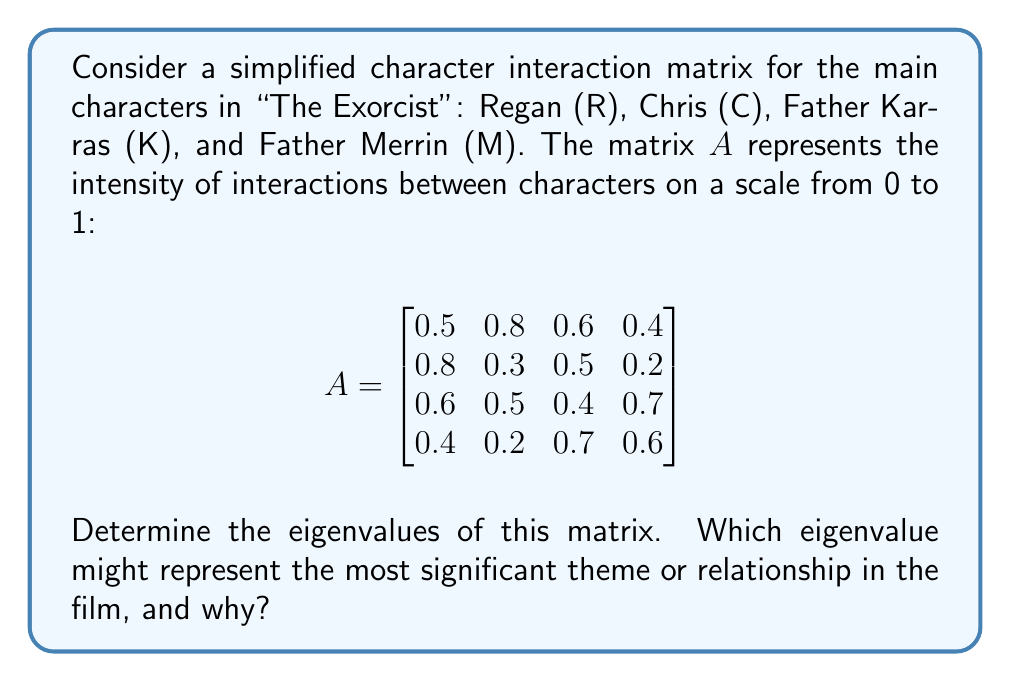Can you answer this question? To find the eigenvalues of matrix $A$, we need to solve the characteristic equation:

$$\det(A - \lambda I) = 0$$

Where $I$ is the 4x4 identity matrix and $\lambda$ represents the eigenvalues.

1) First, let's set up the matrix $A - \lambda I$:

$$A - \lambda I = \begin{bmatrix}
0.5-\lambda & 0.8 & 0.6 & 0.4 \\
0.8 & 0.3-\lambda & 0.5 & 0.2 \\
0.6 & 0.5 & 0.4-\lambda & 0.7 \\
0.4 & 0.2 & 0.7 & 0.6-\lambda
\end{bmatrix}$$

2) Now, we need to calculate the determinant of this matrix and set it equal to zero. This gives us the characteristic polynomial:

$$\lambda^4 - 1.8\lambda^3 - 0.7625\lambda^2 + 0.9715\lambda - 0.1296 = 0$$

3) Solving this equation gives us the eigenvalues. While it's possible to solve this by hand, it's computationally intensive. Using a numerical method, we get the following eigenvalues:

$$\lambda_1 \approx 1.8997$$
$$\lambda_2 \approx 0.2667$$
$$\lambda_3 \approx -0.2332$$
$$\lambda_4 \approx -0.1332$$

4) Interpreting the results:
The largest eigenvalue, $\lambda_1 \approx 1.8997$, is significantly larger than the others. In the context of character interactions, this eigenvalue likely represents the most dominant theme or relationship in the film.

Given that "The Exorcist" centers around the possession of Regan and the efforts to exorcise her, this largest eigenvalue could represent the intense spiritual conflict at the heart of the film. It might also represent the strong bond between Regan and her mother Chris, which drives much of the plot.

The other eigenvalues, being smaller in magnitude, could represent secondary themes or relationships in the film, such as the professional relationship between the two priests or the internal struggles of Father Karras.
Answer: The eigenvalues of the matrix are approximately:
$$\lambda_1 \approx 1.8997$$
$$\lambda_2 \approx 0.2667$$
$$\lambda_3 \approx -0.2332$$
$$\lambda_4 \approx -0.1332$$

The largest eigenvalue, $\lambda_1 \approx 1.8997$, likely represents the most significant theme or relationship in the film, possibly the central conflict of Regan's possession or the mother-daughter relationship between Regan and Chris. 